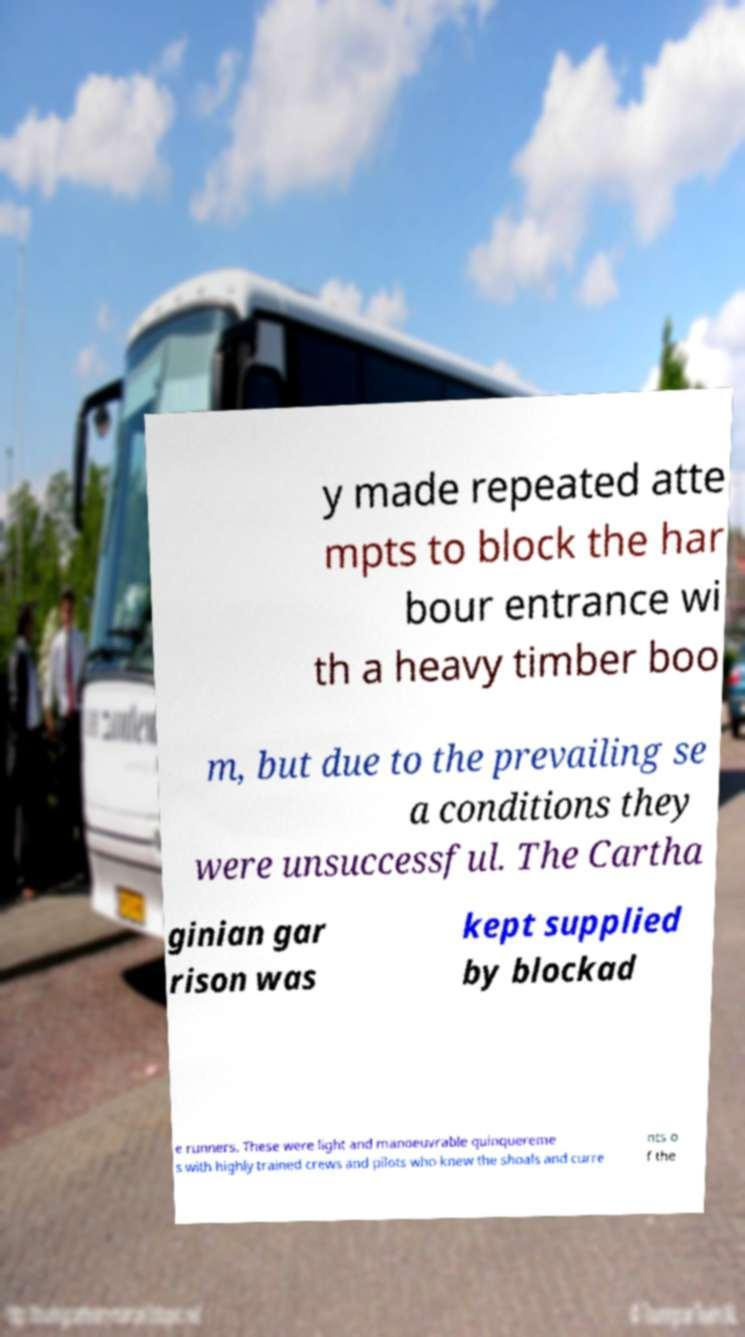Please read and relay the text visible in this image. What does it say? y made repeated atte mpts to block the har bour entrance wi th a heavy timber boo m, but due to the prevailing se a conditions they were unsuccessful. The Cartha ginian gar rison was kept supplied by blockad e runners. These were light and manoeuvrable quinquereme s with highly trained crews and pilots who knew the shoals and curre nts o f the 